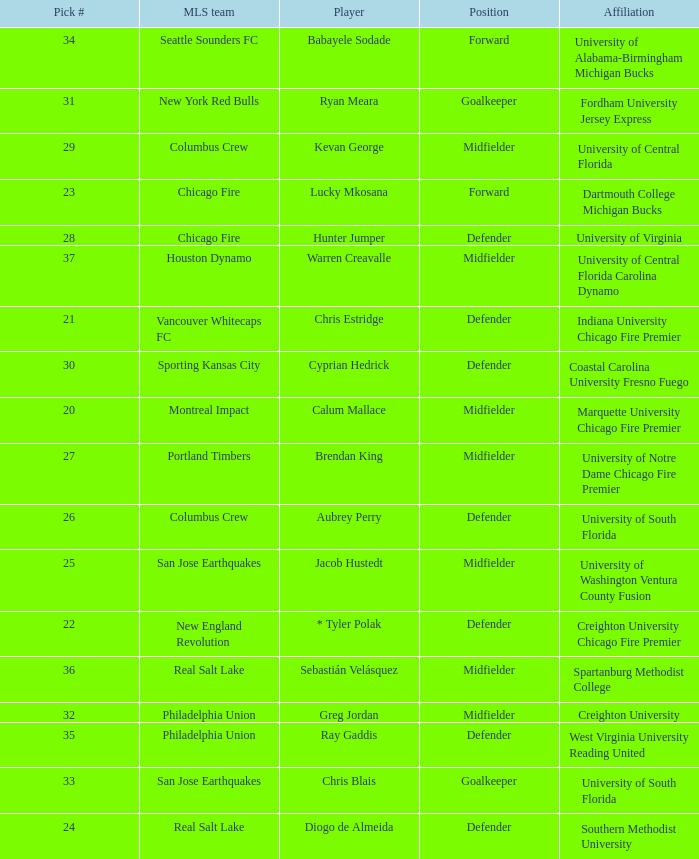What pick number is Kevan George? 29.0. 